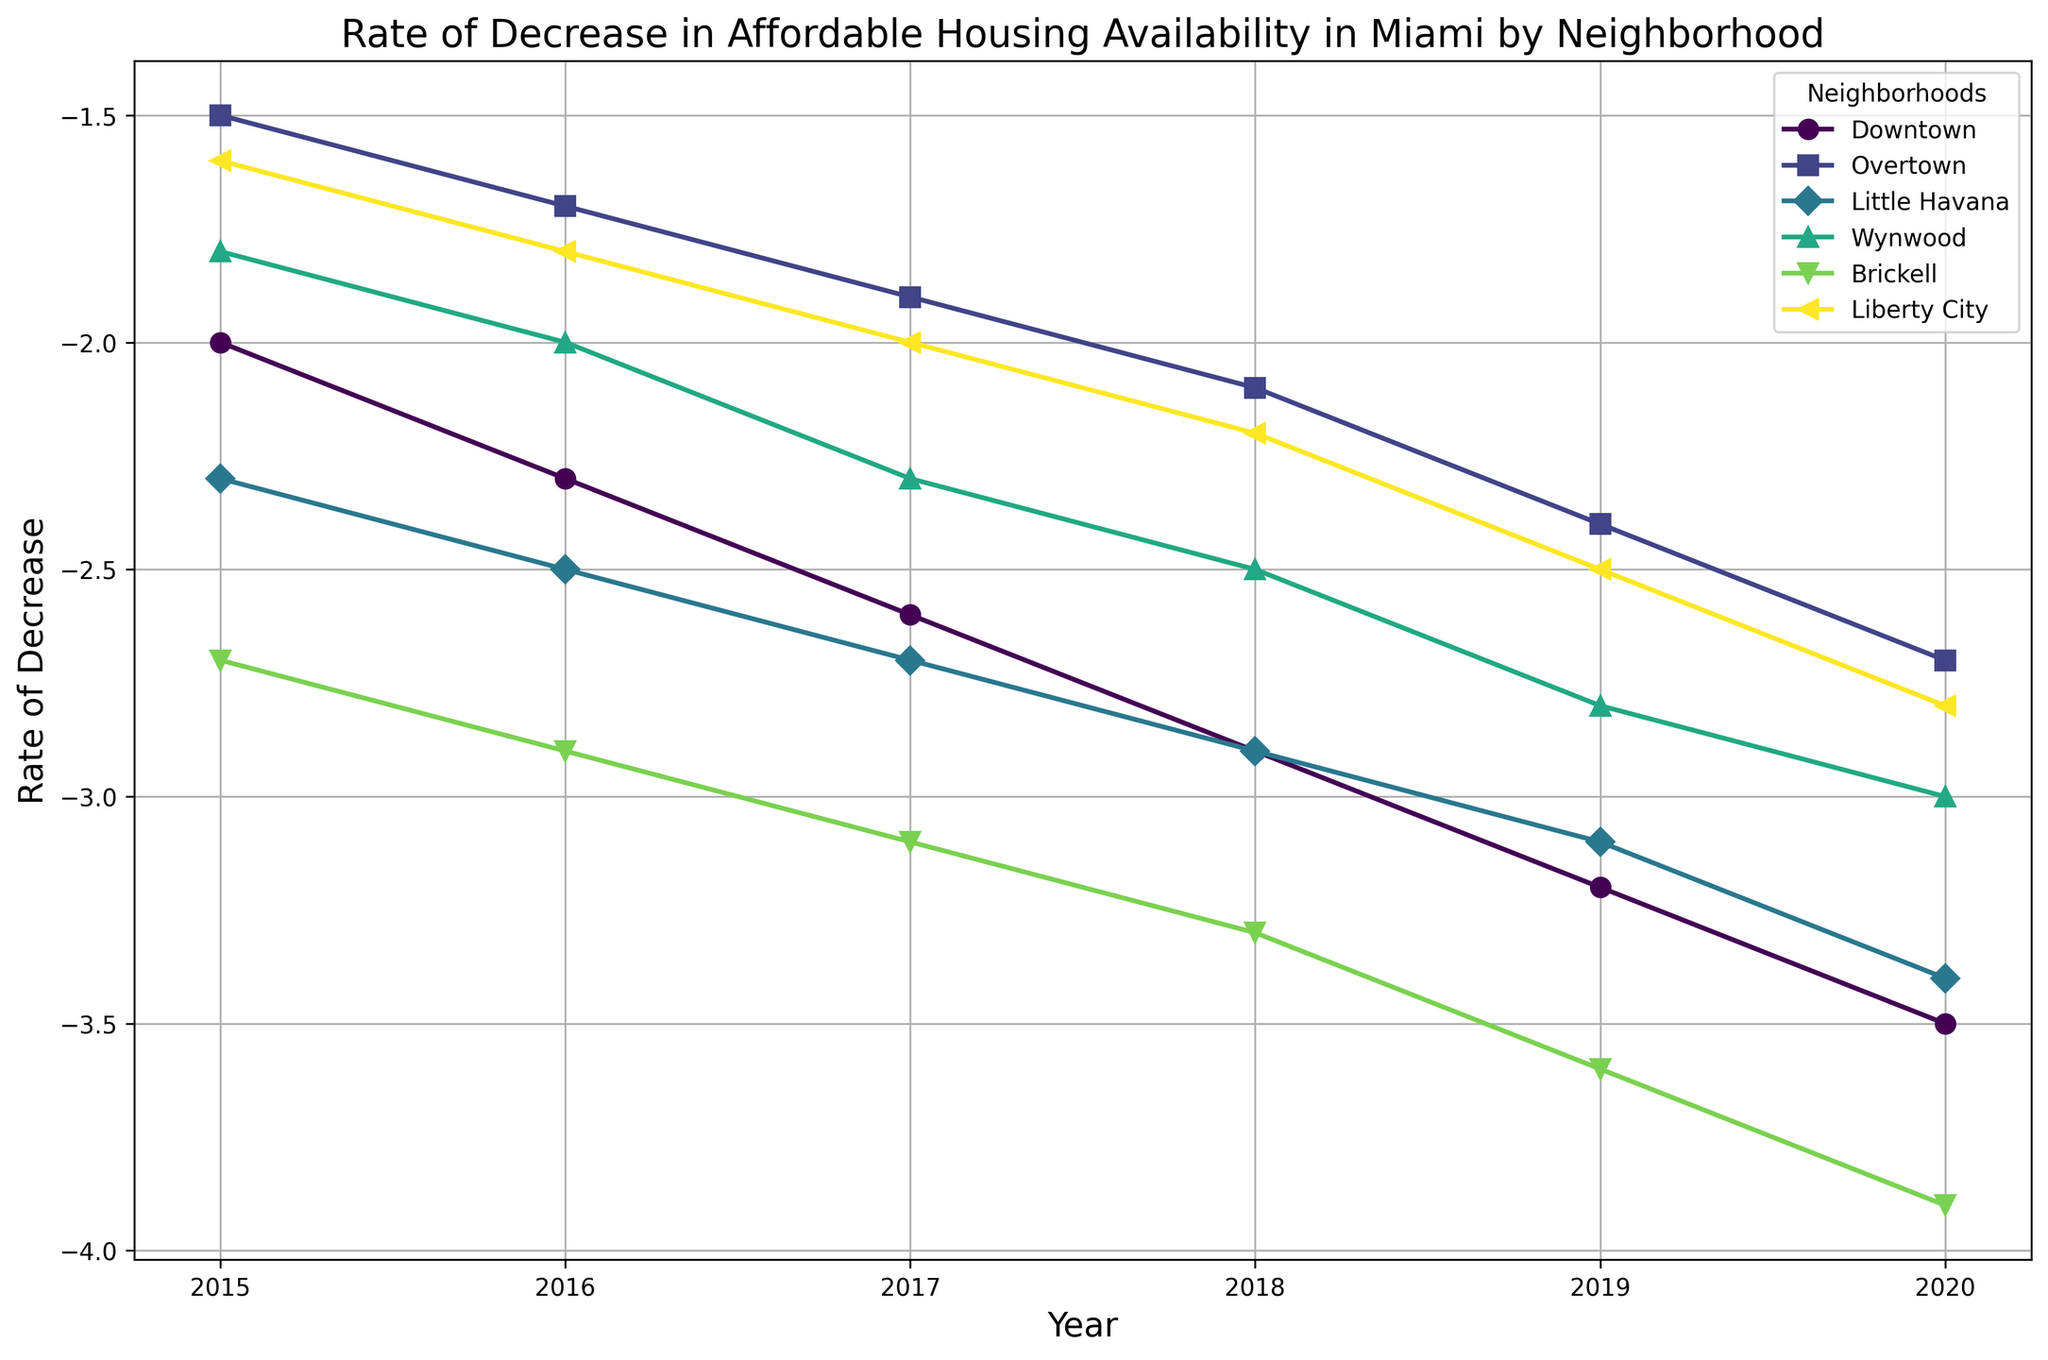What's the rate of decrease in affordable housing availability for Brickell in 2019? To find the rate of decrease for Brickell in 2019, locate the Brickell line on the plot and identify its value at the 2019 mark on the x-axis. The value is -3.6.
Answer: -3.6 Which neighborhood had the highest rate of decrease in affordable housing availability in 2020? To determine this, compare the rates of decrease in 2020 across all neighborhoods in the plot. The neighborhood with the most negative value is Brickell, with a rate of -3.9.
Answer: Brickell Between Downtown and Little Havana, which neighborhood experienced a steadier decline in affordable housing availability between 2015 and 2020? To check for a steadier decline, observe the lines representing Downtown and Little Havana from 2015 to 2020. Both show steady declines, but Little Havana has a more uniform slope while Downtown's slope is slightly steeper in the later years. Little Havana shows a steadier pattern.
Answer: Little Havana What is the difference in the rate of decrease in affordable housing availability between Downtown and Liberty City in 2020? Find the rate of decrease for Downtown and Liberty City in 2020. Downtown's rate is -3.5 and Liberty City's rate is -2.8. Subtract -2.8 from -3.5: -3.5 - (-2.8) = -0.7.
Answer: -0.7 Which neighborhood shows the smallest rate of decrease in affordable housing availability in 2016? Look at the 2016 values across all neighborhood lines and identify the one with the least negative value. Overtown shows the smallest decrease at -1.7.
Answer: Overtown How did the rate of decrease in affordable housing availability for Wynwood change from 2015 to 2019? Identify Wynwood's rates for 2015 and 2019. In 2015, the rate is -1.8 and in 2019, it is -2.8. The difference is -2.8 - (-1.8) = -1.0, indicating a decrease of 1.0 units.
Answer: -1.0 Compare the visual consistency of the line plots for Brickell and Overtown; which one is more consistent in its trend? Visual consistency refers to how uniform the line is. Brickell's line has a steep and steady downward slope while Overtown's line is less steep and shows a more gradual and uniform decrease. Overtown exhibits more consistent behavior.
Answer: Overtown What's the average rate of decrease in affordable housing for Little Havana over the years shown? To find the average, sum the rates for Little Havana from 2015 to 2020: -2.3 + -2.5 + -2.7 + -2.9 + -3.1 + -3.4 = -16.9. Then divide by the number of years: -16.9/6 ≈ -2.82.
Answer: -2.82 